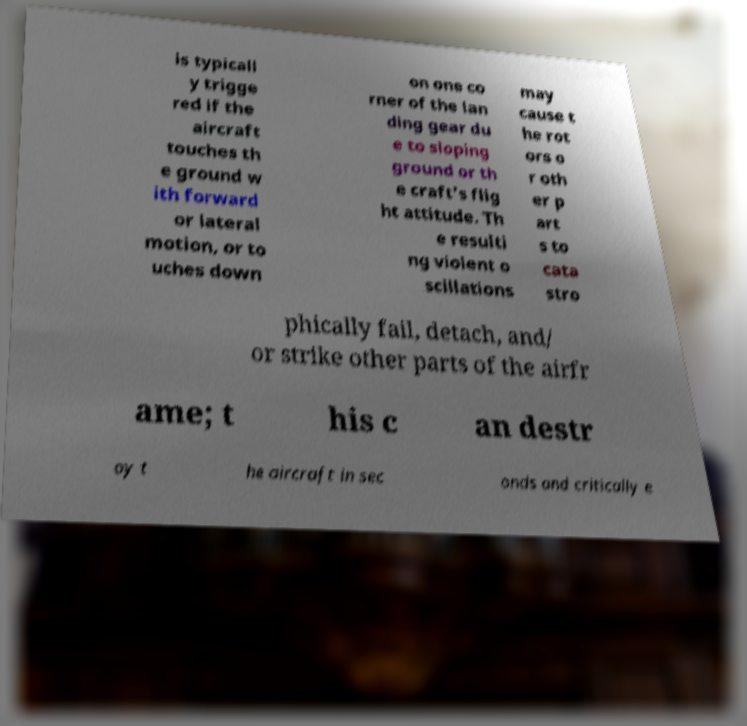Can you read and provide the text displayed in the image?This photo seems to have some interesting text. Can you extract and type it out for me? is typicall y trigge red if the aircraft touches th e ground w ith forward or lateral motion, or to uches down on one co rner of the lan ding gear du e to sloping ground or th e craft's flig ht attitude. Th e resulti ng violent o scillations may cause t he rot ors o r oth er p art s to cata stro phically fail, detach, and/ or strike other parts of the airfr ame; t his c an destr oy t he aircraft in sec onds and critically e 